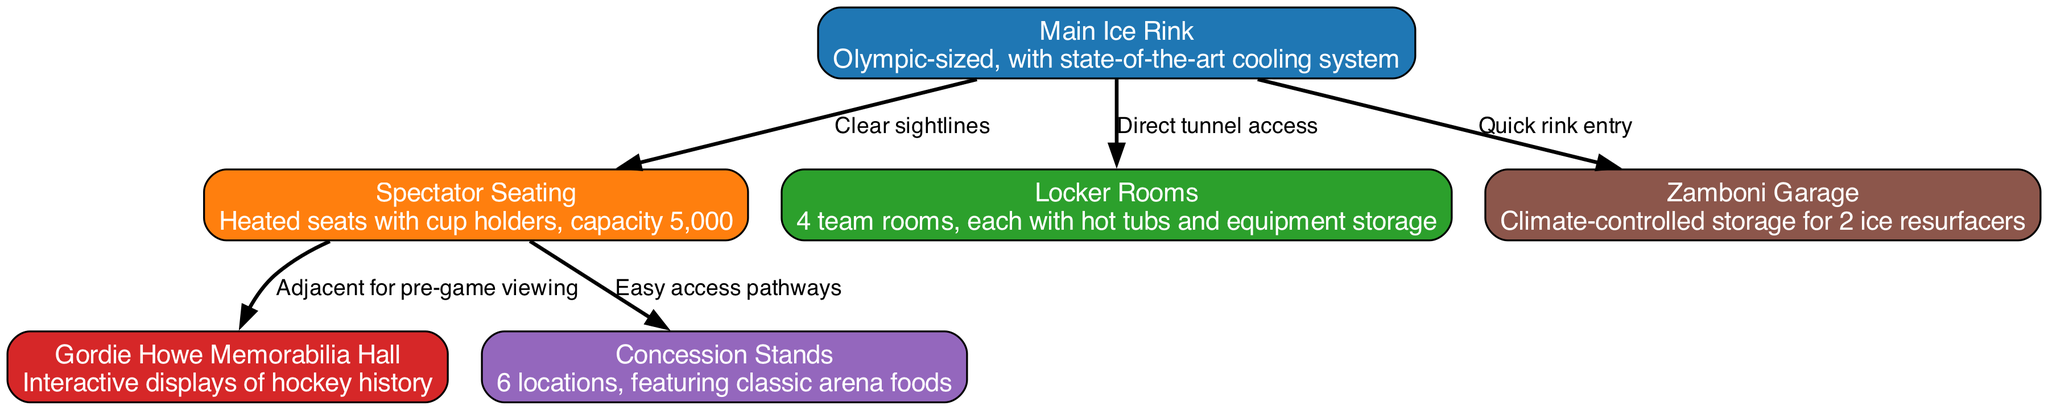What's the capacity of the spectator seating? The diagram states that the spectator seating has a capacity of 5,000. This is directly mentioned in the details of the "Spectator Seating" node.
Answer: 5,000 How many locker rooms are there? The "Locker Rooms" node specifies that there are 4 team rooms. This information is explicitly given in the details section of that node.
Answer: 4 What type of display is featured in the Gordie Howe Memorabilia Hall? According to the "Gordie Howe Memorabilia Hall" node, it contains interactive displays of hockey history. This detail can be found directly in the node's description.
Answer: Interactive displays of hockey history Which facility has direct tunnel access to the main ice rink? The diagram shows that "Locker Rooms" has direct tunnel access to the "Main Ice Rink," as indicated by the connecting edge. This information is extracted from the edge label connecting the two nodes.
Answer: Locker Rooms What feature is provided with the spectator seating? The details of the "Spectator Seating" node mention that they have heated seats with cup holders. This is stated clearly in the description of that particular node.
Answer: Heated seats with cup holders How many concession stands are there in total? The number of concession stands is detailed in the "Concession Stands" node, stating there are 6 locations. This can be seen directly in the specifics of that node.
Answer: 6 What is the primary access aspect of the Zamboni garage? According to the diagram's edges, the "Zamboni Garage" is connected to the "Main Ice Rink" with a label indicating "Quick rink entry." This explains the main access aspect of the garage.
Answer: Quick rink entry What connects the spectator seating to the concession stands? The "Easy access pathways" label on the edge between "Spectator Seating" and "Concession Stands" indicates the connection between these two facilities, allowing for easy movement.
Answer: Easy access pathways Which node is adjacent for pre-game viewing? The relationship between the "Spectator Seating" and "Gordie Howe Memorabilia Hall" nodes indicates that the Gordie Howe Memorial Hall is adjacent for pre-game viewing, as described in the edge label.
Answer: Gordie Howe Memorabilia Hall 